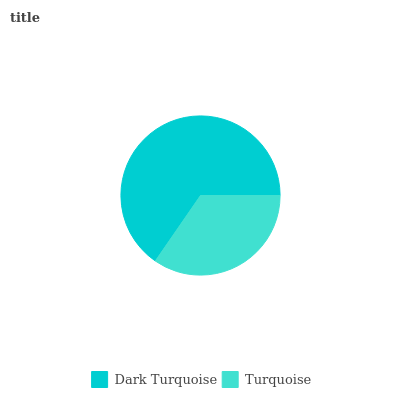Is Turquoise the minimum?
Answer yes or no. Yes. Is Dark Turquoise the maximum?
Answer yes or no. Yes. Is Turquoise the maximum?
Answer yes or no. No. Is Dark Turquoise greater than Turquoise?
Answer yes or no. Yes. Is Turquoise less than Dark Turquoise?
Answer yes or no. Yes. Is Turquoise greater than Dark Turquoise?
Answer yes or no. No. Is Dark Turquoise less than Turquoise?
Answer yes or no. No. Is Dark Turquoise the high median?
Answer yes or no. Yes. Is Turquoise the low median?
Answer yes or no. Yes. Is Turquoise the high median?
Answer yes or no. No. Is Dark Turquoise the low median?
Answer yes or no. No. 